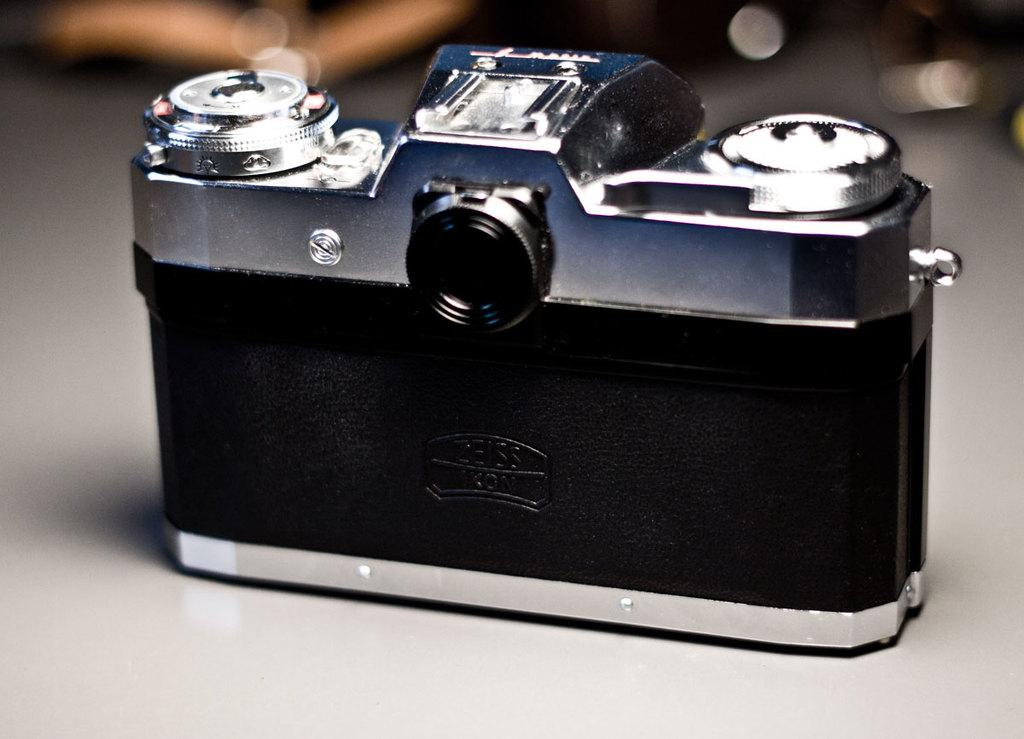What is the main subject in the center of the image? There is a camera in the center of the image. Can you describe the position of the camera in the image? The camera is on a surface in the image. What can be observed about the background of the image? The background of the image is blurred. What type of food is being served on the stage in the image? There is no food or stage present in the image; it features a camera on a surface with a blurred background. What type of plant can be seen growing near the camera in the image? There is no plant visible near the camera in the image. 